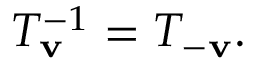<formula> <loc_0><loc_0><loc_500><loc_500>T _ { v } ^ { - 1 } = T _ { - v } .</formula> 